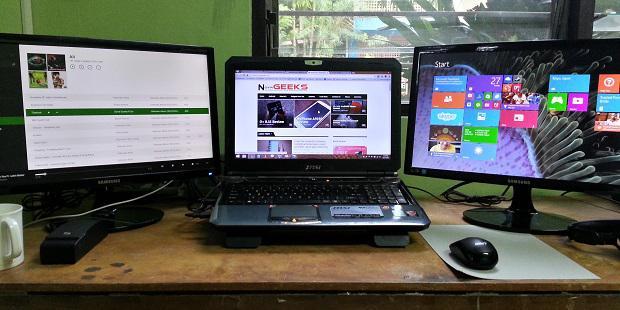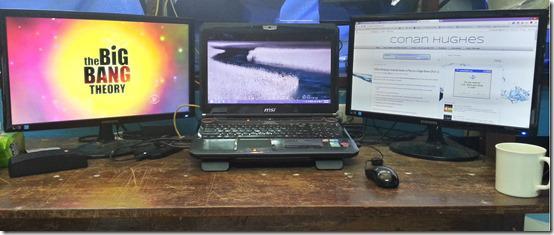The first image is the image on the left, the second image is the image on the right. Analyze the images presented: Is the assertion "The external monitors are showing the same image as the laptop." valid? Answer yes or no. No. The first image is the image on the left, the second image is the image on the right. For the images displayed, is the sentence "Three computer screens are lined up in each picture." factually correct? Answer yes or no. Yes. 